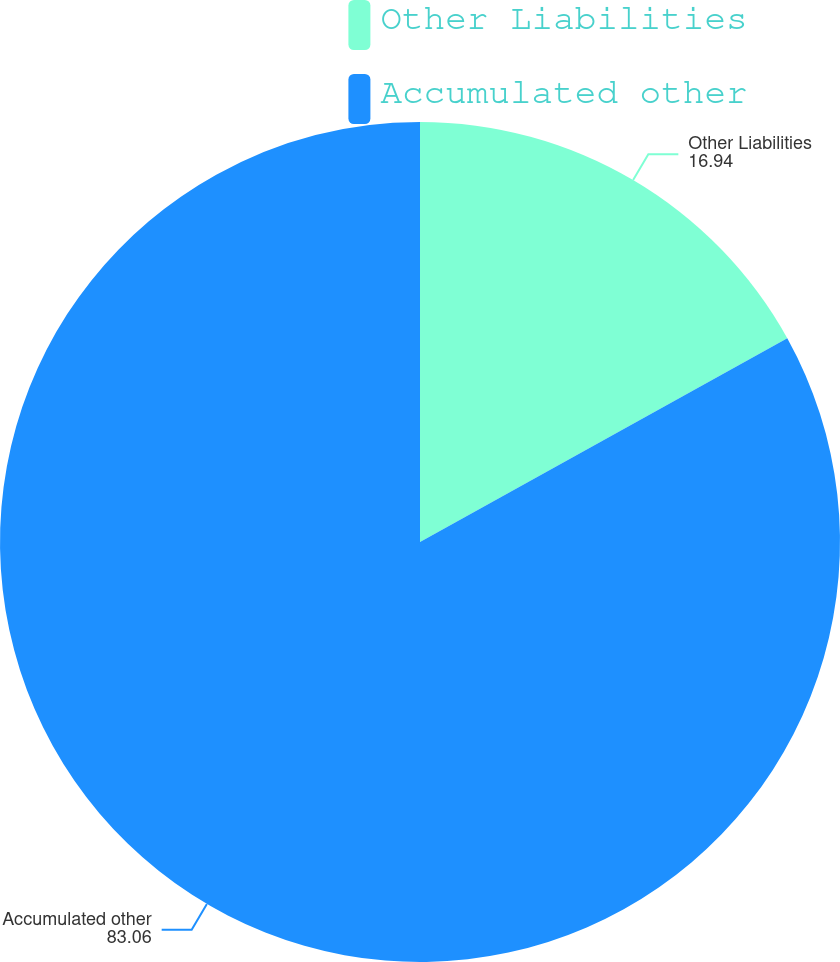Convert chart to OTSL. <chart><loc_0><loc_0><loc_500><loc_500><pie_chart><fcel>Other Liabilities<fcel>Accumulated other<nl><fcel>16.94%<fcel>83.06%<nl></chart> 